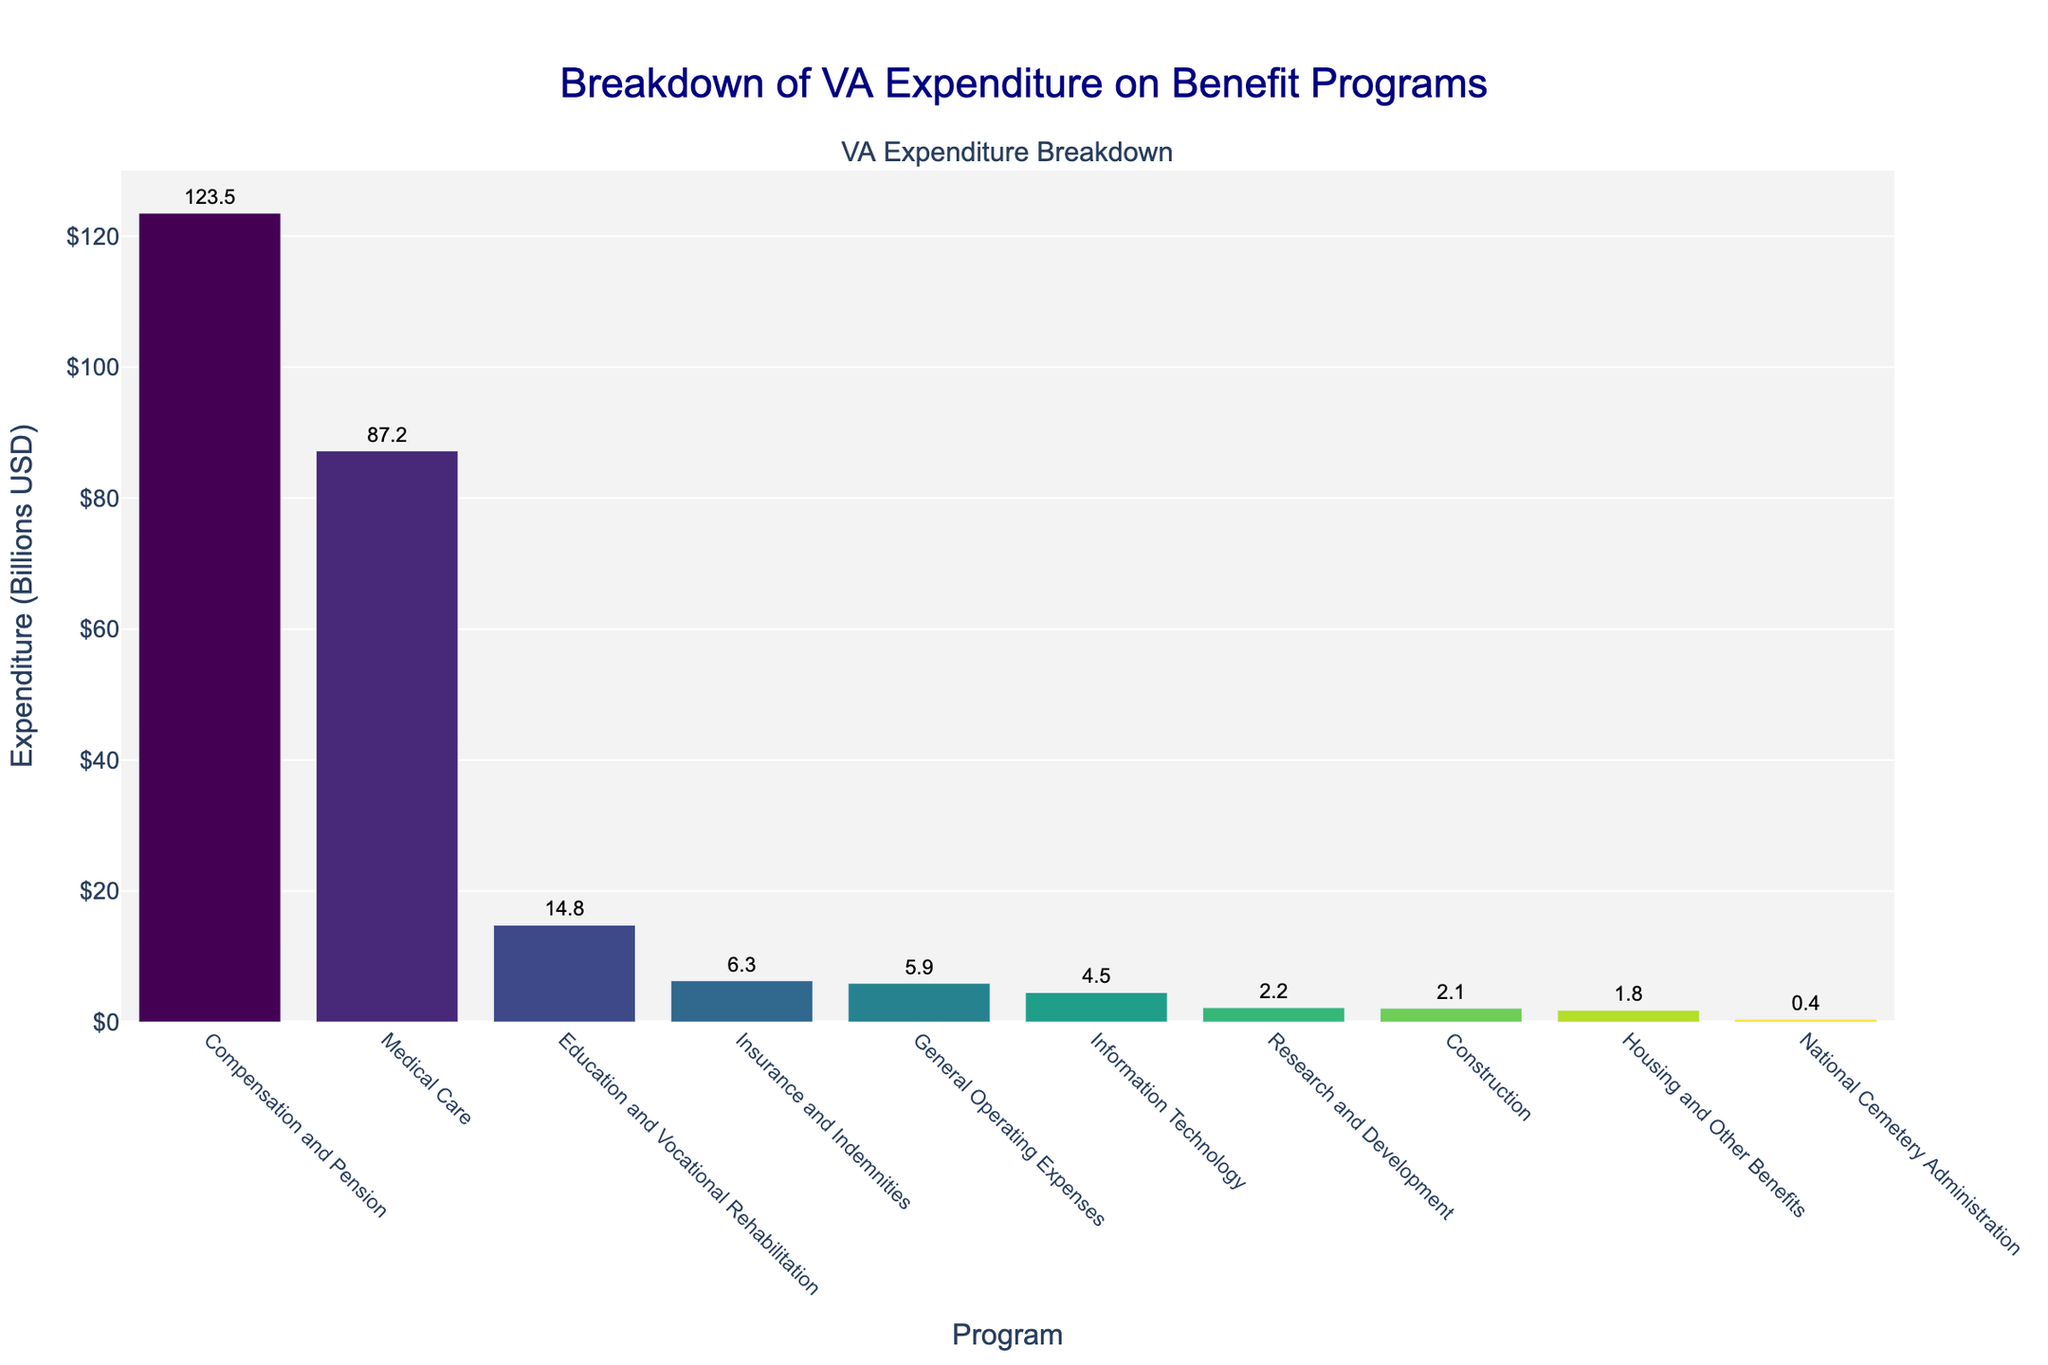What program has the highest expenditure? The bar representing Compensation and Pension is the tallest in the plot, indicating it has the highest expenditure.
Answer: Compensation and Pension How much more is spent on Medical Care than on Education and Vocational Rehabilitation? The expenditure on Medical Care is $87.2 billion, and on Education and Vocational Rehabilitation is $14.8 billion. The difference is $87.2 billion - $14.8 billion.
Answer: $72.4 billion Which program has the lowest expenditure? The bar representing National Cemetery Administration is the shortest in the plot, indicating it has the lowest expenditure.
Answer: National Cemetery Administration What is the total expenditure for Veterinary Affairs benefit programs (total of all bars)? Adding up all expenditures: $123.5 (Compensation and Pension) + $87.2 (Medical Care) + $14.8 (Education and Vocational Rehabilitation) + $6.3 (Insurance and Indemnities) + $5.9 (General Operating Expenses) + $2.1 (Construction) + $1.8 (Housing and Other Benefits) + $4.5 (Information Technology) + $2.2 (Research and Development) + $0.4 (National Cemetery Administration). Summing these values gives $248.7 billion.
Answer: $248.7 billion How many programs have an expenditure of more than $10 billion? The programs with expenditures greater than $10 billion are Compensation and Pension, Medical Care, and Education and Vocational Rehabilitation—counting these results in 3 programs.
Answer: 3 programs What is the expenditure difference between Insurance and Indemnities and Information Technology? The expenditure for Insurance and Indemnities is $6.3 billion and for Information Technology is $4.5 billion. The difference is $6.3 billion - $4.5 billion.
Answer: $1.8 billion Which programs have expenditures between $2 billion and $10 billion? The programs in this expenditure range are Insurance and Indemnities ($6.3 billion), General Operating Expenses ($5.9 billion), Information Technology ($4.5 billion), and Research and Development ($2.2 billion).
Answer: Insurance and Indemnities, General Operating Expenses, Information Technology, Research and Development Is the expenditure on Medical Care higher than the combined expenditure on Housing and Other Benefits and Construction? The expenditure on Medical Care is $87.2 billion, and the combined expenditure on Housing and Other Benefits ($1.8 billion) and Construction ($2.1 billion) is $1.8 billion + $2.1 billion = $3.9 billion. Since $87.2 billion is greater than $3.9 billion, Medical Care has a higher expenditure.
Answer: Yes, it is higher What is the combined expenditure of the three programs with the lowest expenditure? The three programs with the lowest expenditures are National Cemetery Administration ($0.4 billion), Housing and Other Benefits ($1.8 billion), and Construction ($2.1 billion). The combined expenditure is $0.4 billion + $1.8 billion + $2.1 billion.
Answer: $4.3 billion 